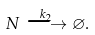Convert formula to latex. <formula><loc_0><loc_0><loc_500><loc_500>N \stackrel { k _ { 2 } } \longrightarrow \varnothing .</formula> 